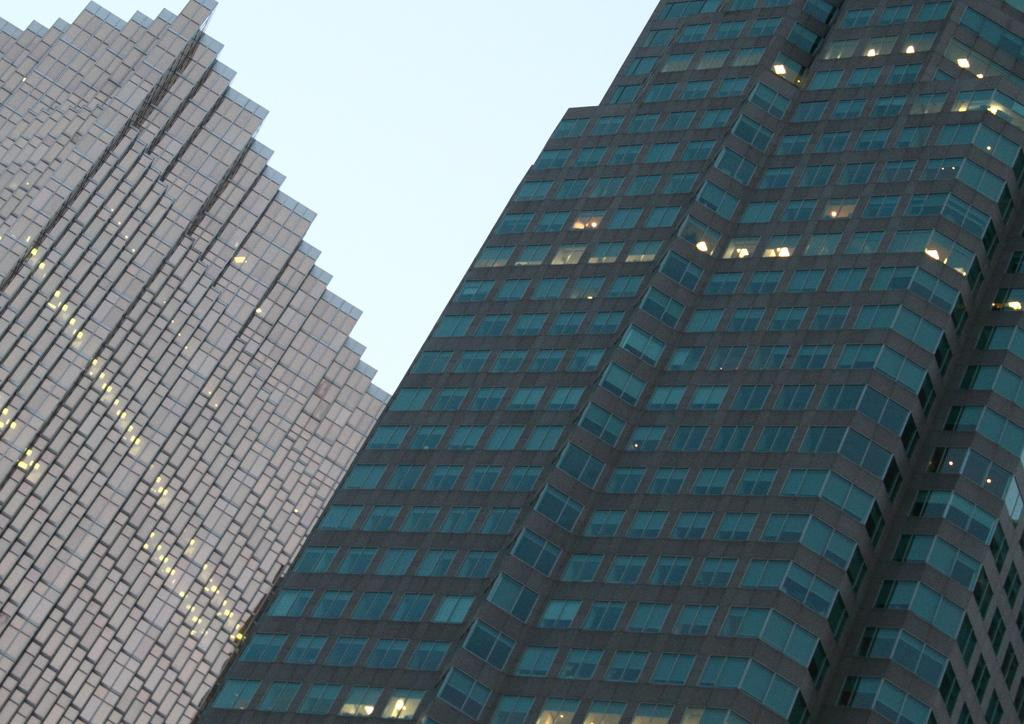What structures are present in the image? There are buildings in the image. What can be seen in the background of the image? The sky is visible in the background of the image. Can you tell me how many donkeys are standing next to the buildings in the image? There are no donkeys present in the image; it only features buildings and the sky. What type of machine is being used by the friends in the image? There are no friends or machines present in the image; it only features buildings and the sky. 